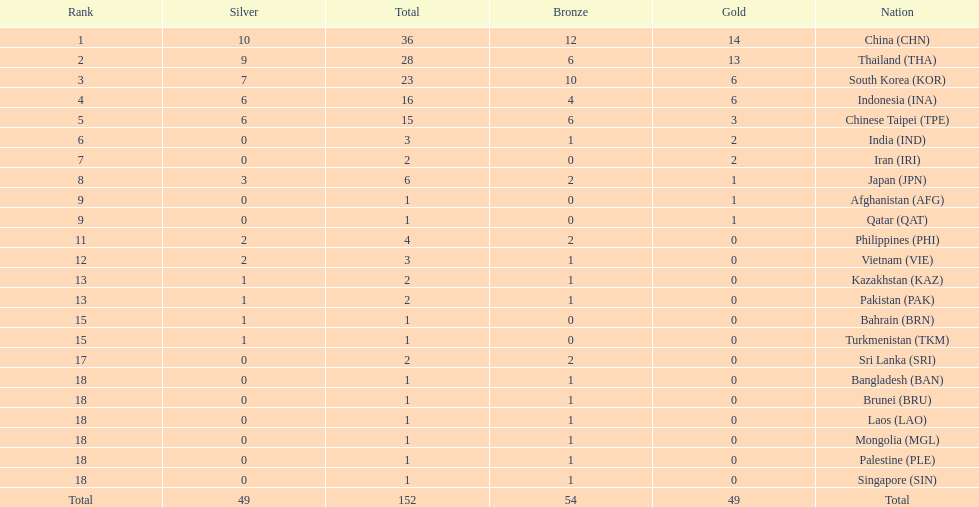How many total gold medal have been given? 49. Write the full table. {'header': ['Rank', 'Silver', 'Total', 'Bronze', 'Gold', 'Nation'], 'rows': [['1', '10', '36', '12', '14', 'China\xa0(CHN)'], ['2', '9', '28', '6', '13', 'Thailand\xa0(THA)'], ['3', '7', '23', '10', '6', 'South Korea\xa0(KOR)'], ['4', '6', '16', '4', '6', 'Indonesia\xa0(INA)'], ['5', '6', '15', '6', '3', 'Chinese Taipei\xa0(TPE)'], ['6', '0', '3', '1', '2', 'India\xa0(IND)'], ['7', '0', '2', '0', '2', 'Iran\xa0(IRI)'], ['8', '3', '6', '2', '1', 'Japan\xa0(JPN)'], ['9', '0', '1', '0', '1', 'Afghanistan\xa0(AFG)'], ['9', '0', '1', '0', '1', 'Qatar\xa0(QAT)'], ['11', '2', '4', '2', '0', 'Philippines\xa0(PHI)'], ['12', '2', '3', '1', '0', 'Vietnam\xa0(VIE)'], ['13', '1', '2', '1', '0', 'Kazakhstan\xa0(KAZ)'], ['13', '1', '2', '1', '0', 'Pakistan\xa0(PAK)'], ['15', '1', '1', '0', '0', 'Bahrain\xa0(BRN)'], ['15', '1', '1', '0', '0', 'Turkmenistan\xa0(TKM)'], ['17', '0', '2', '2', '0', 'Sri Lanka\xa0(SRI)'], ['18', '0', '1', '1', '0', 'Bangladesh\xa0(BAN)'], ['18', '0', '1', '1', '0', 'Brunei\xa0(BRU)'], ['18', '0', '1', '1', '0', 'Laos\xa0(LAO)'], ['18', '0', '1', '1', '0', 'Mongolia\xa0(MGL)'], ['18', '0', '1', '1', '0', 'Palestine\xa0(PLE)'], ['18', '0', '1', '1', '0', 'Singapore\xa0(SIN)'], ['Total', '49', '152', '54', '49', 'Total']]} 